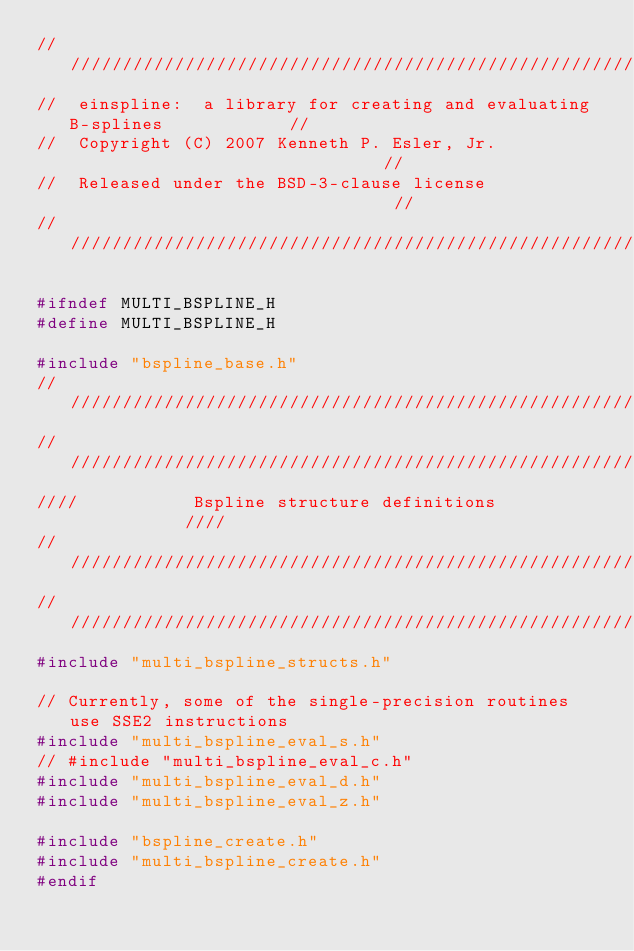Convert code to text. <code><loc_0><loc_0><loc_500><loc_500><_C_>/////////////////////////////////////////////////////////////////////////////
//  einspline:  a library for creating and evaluating B-splines            //
//  Copyright (C) 2007 Kenneth P. Esler, Jr.                               //
//  Released under the BSD-3-clause license                                //
/////////////////////////////////////////////////////////////////////////////

#ifndef MULTI_BSPLINE_H
#define MULTI_BSPLINE_H

#include "bspline_base.h"
////////////////////////////////////////////////////////////
////////////////////////////////////////////////////////////
////           Bspline structure definitions            ////
////////////////////////////////////////////////////////////
////////////////////////////////////////////////////////////
#include "multi_bspline_structs.h"

// Currently, some of the single-precision routines use SSE2 instructions
#include "multi_bspline_eval_s.h"
// #include "multi_bspline_eval_c.h"
#include "multi_bspline_eval_d.h"
#include "multi_bspline_eval_z.h"

#include "bspline_create.h"
#include "multi_bspline_create.h"
#endif
</code> 